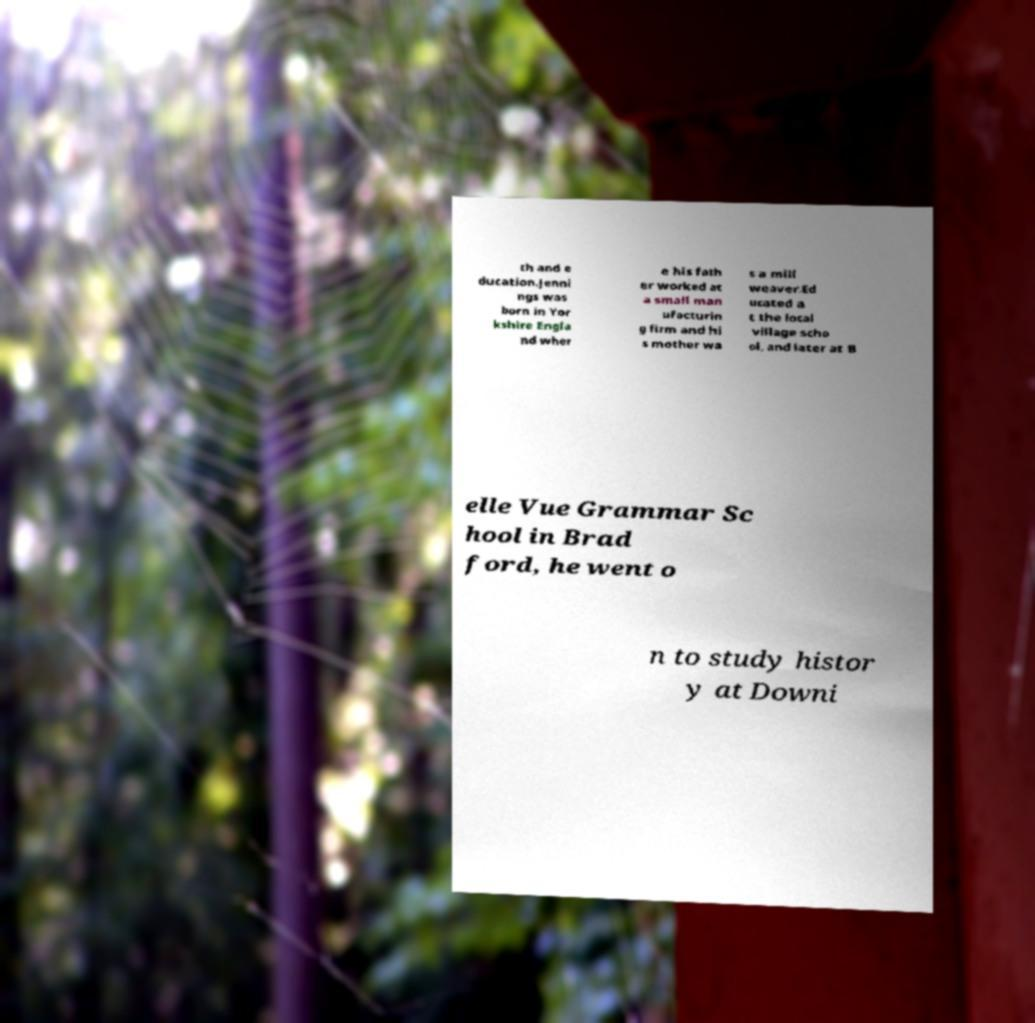There's text embedded in this image that I need extracted. Can you transcribe it verbatim? th and e ducation.Jenni ngs was born in Yor kshire Engla nd wher e his fath er worked at a small man ufacturin g firm and hi s mother wa s a mill weaver.Ed ucated a t the local village scho ol, and later at B elle Vue Grammar Sc hool in Brad ford, he went o n to study histor y at Downi 